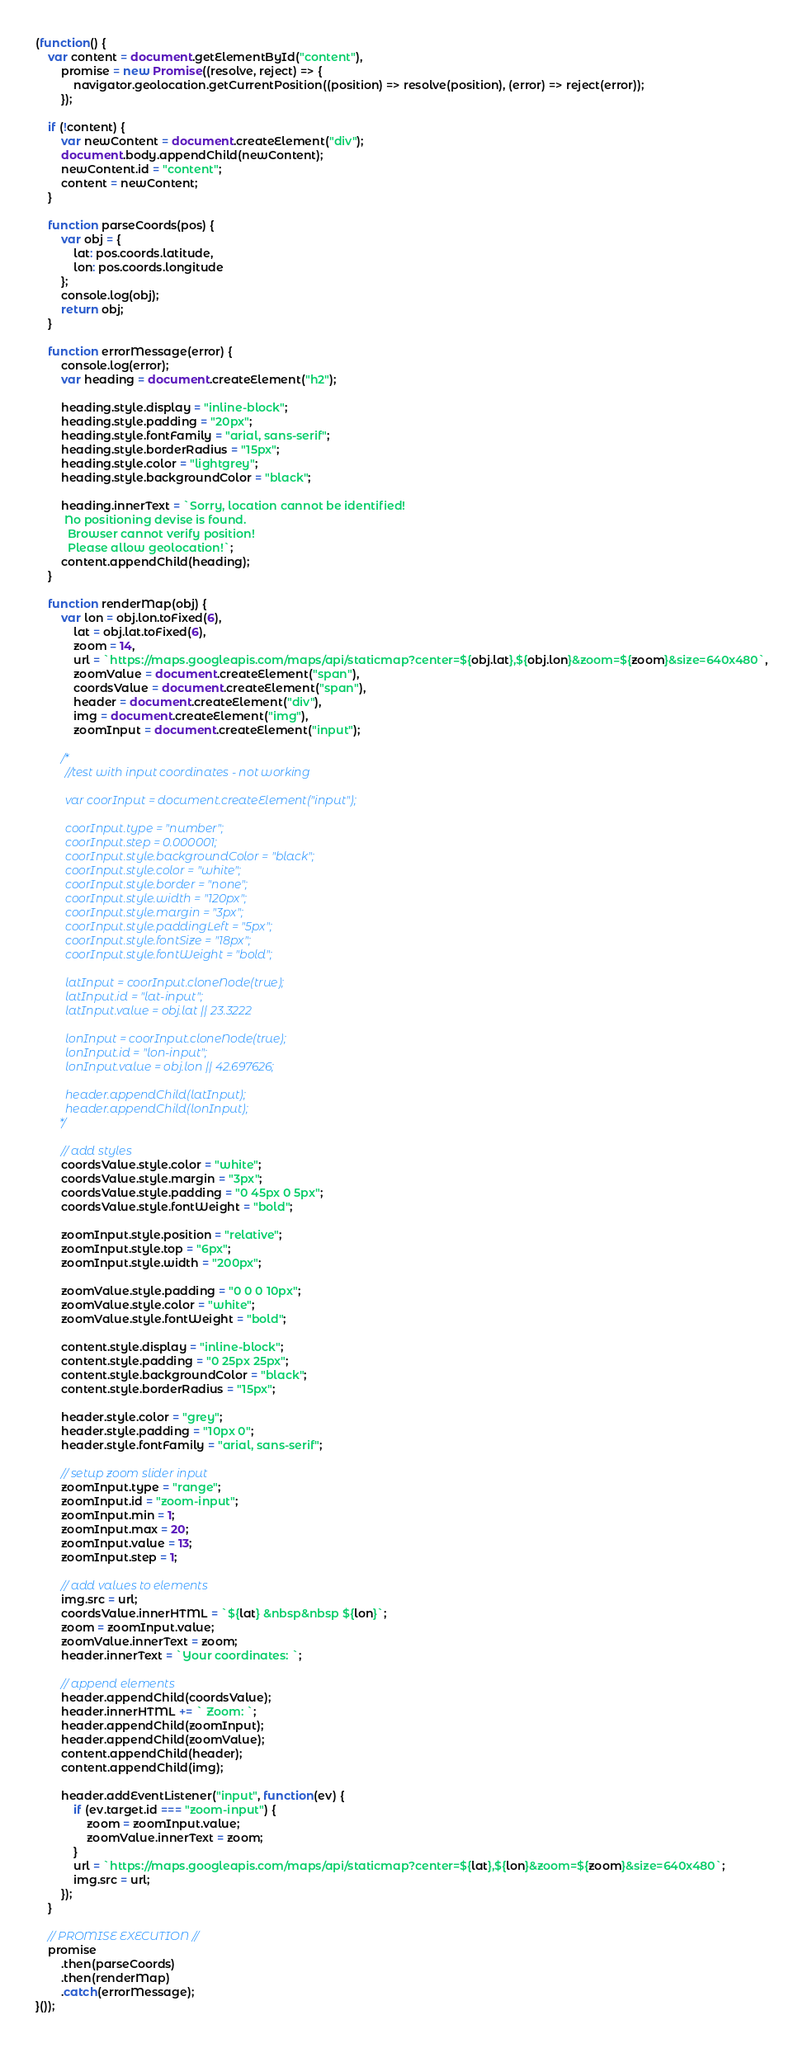<code> <loc_0><loc_0><loc_500><loc_500><_JavaScript_>(function() {
    var content = document.getElementById("content"),
        promise = new Promise((resolve, reject) => {
            navigator.geolocation.getCurrentPosition((position) => resolve(position), (error) => reject(error));
        });

    if (!content) {
        var newContent = document.createElement("div");
        document.body.appendChild(newContent);
        newContent.id = "content";
        content = newContent;
    }

    function parseCoords(pos) {
        var obj = {
            lat: pos.coords.latitude,
            lon: pos.coords.longitude
        };
        console.log(obj);
        return obj;
    }

    function errorMessage(error) {
        console.log(error);
        var heading = document.createElement("h2");

        heading.style.display = "inline-block";
        heading.style.padding = "20px";
        heading.style.fontFamily = "arial, sans-serif";
        heading.style.borderRadius = "15px";
        heading.style.color = "lightgrey";
        heading.style.backgroundColor = "black";

        heading.innerText = `Sorry, location cannot be identified!
         No positioning devise is found.
          Browser cannot verify position!
          Please allow geolocation!`;
        content.appendChild(heading);
    }

    function renderMap(obj) {
        var lon = obj.lon.toFixed(6),
            lat = obj.lat.toFixed(6),
            zoom = 14,
            url = `https://maps.googleapis.com/maps/api/staticmap?center=${obj.lat},${obj.lon}&zoom=${zoom}&size=640x480`,
            zoomValue = document.createElement("span"),
            coordsValue = document.createElement("span"),
            header = document.createElement("div"),
            img = document.createElement("img"),
            zoomInput = document.createElement("input");

        /*
          //test with input coordinates - not working
          
          var coorInput = document.createElement("input");
        
          coorInput.type = "number";
          coorInput.step = 0.000001;
          coorInput.style.backgroundColor = "black";
          coorInput.style.color = "white";
          coorInput.style.border = "none";
          coorInput.style.width = "120px";
          coorInput.style.margin = "3px";
          coorInput.style.paddingLeft = "5px";
          coorInput.style.fontSize = "18px";
          coorInput.style.fontWeight = "bold";
              
          latInput = coorInput.cloneNode(true);
          latInput.id = "lat-input";
          latInput.value = obj.lat || 23.3222

          lonInput = coorInput.cloneNode(true);
          lonInput.id = "lon-input";
          lonInput.value = obj.lon || 42.697626;

          header.appendChild(latInput);
          header.appendChild(lonInput);
        */

        // add styles
        coordsValue.style.color = "white";
        coordsValue.style.margin = "3px";
        coordsValue.style.padding = "0 45px 0 5px";
        coordsValue.style.fontWeight = "bold";

        zoomInput.style.position = "relative";
        zoomInput.style.top = "6px";
        zoomInput.style.width = "200px";

        zoomValue.style.padding = "0 0 0 10px";
        zoomValue.style.color = "white";
        zoomValue.style.fontWeight = "bold";

        content.style.display = "inline-block";
        content.style.padding = "0 25px 25px";
        content.style.backgroundColor = "black";
        content.style.borderRadius = "15px";

        header.style.color = "grey";
        header.style.padding = "10px 0";
        header.style.fontFamily = "arial, sans-serif";

        // setup zoom slider input
        zoomInput.type = "range";
        zoomInput.id = "zoom-input";
        zoomInput.min = 1;
        zoomInput.max = 20;
        zoomInput.value = 13;
        zoomInput.step = 1;

        // add values to elements
        img.src = url;
        coordsValue.innerHTML = `${lat} &nbsp&nbsp ${lon}`;
        zoom = zoomInput.value;
        zoomValue.innerText = zoom;
        header.innerText = `Your coordinates: `;

        // append elements
        header.appendChild(coordsValue);
        header.innerHTML += ` Zoom: `;
        header.appendChild(zoomInput);
        header.appendChild(zoomValue);
        content.appendChild(header);
        content.appendChild(img);

        header.addEventListener("input", function(ev) {
            if (ev.target.id === "zoom-input") {
                zoom = zoomInput.value;
                zoomValue.innerText = zoom;
            }
            url = `https://maps.googleapis.com/maps/api/staticmap?center=${lat},${lon}&zoom=${zoom}&size=640x480`;
            img.src = url;
        });
    }

    // PROMISE EXECUTION //
    promise
        .then(parseCoords)
        .then(renderMap)
        .catch(errorMessage);
}());</code> 